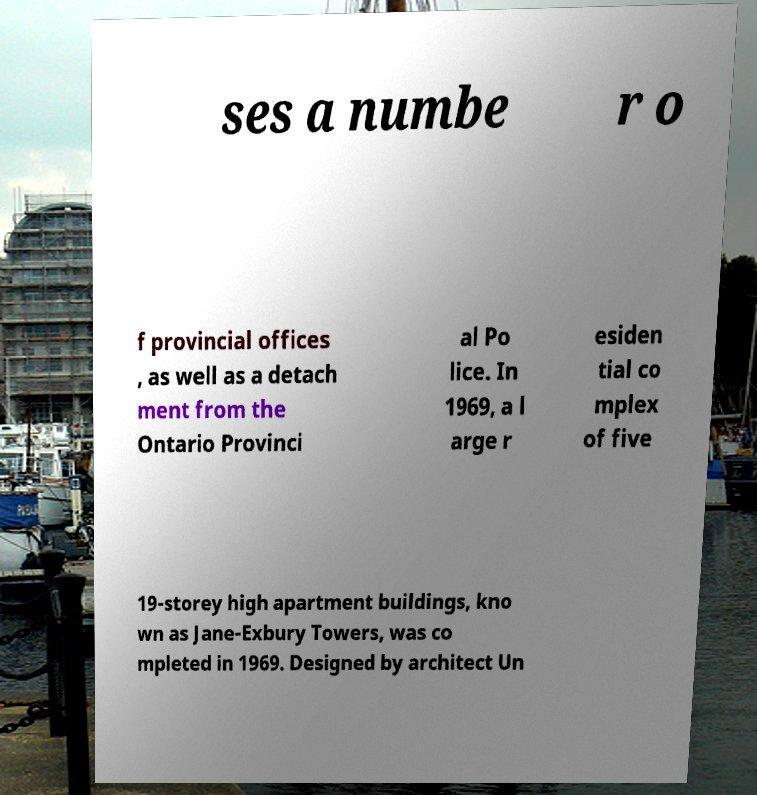I need the written content from this picture converted into text. Can you do that? ses a numbe r o f provincial offices , as well as a detach ment from the Ontario Provinci al Po lice. In 1969, a l arge r esiden tial co mplex of five 19-storey high apartment buildings, kno wn as Jane-Exbury Towers, was co mpleted in 1969. Designed by architect Un 